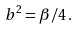<formula> <loc_0><loc_0><loc_500><loc_500>b ^ { 2 } = \beta / 4 \, .</formula> 